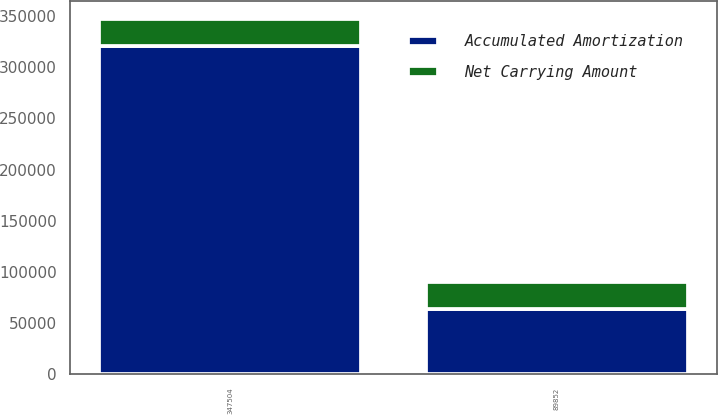Convert chart to OTSL. <chart><loc_0><loc_0><loc_500><loc_500><stacked_bar_chart><ecel><fcel>89852<fcel>347504<nl><fcel>Net Carrying Amount<fcel>26701<fcel>26701<nl><fcel>Accumulated Amortization<fcel>63151<fcel>320803<nl></chart> 